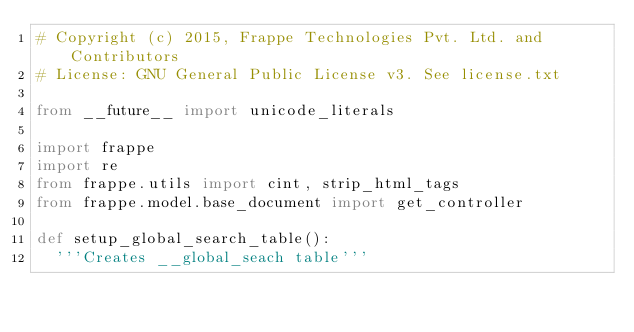<code> <loc_0><loc_0><loc_500><loc_500><_Python_># Copyright (c) 2015, Frappe Technologies Pvt. Ltd. and Contributors
# License: GNU General Public License v3. See license.txt

from __future__ import unicode_literals

import frappe
import re
from frappe.utils import cint, strip_html_tags
from frappe.model.base_document import get_controller

def setup_global_search_table():
	'''Creates __global_seach table'''</code> 